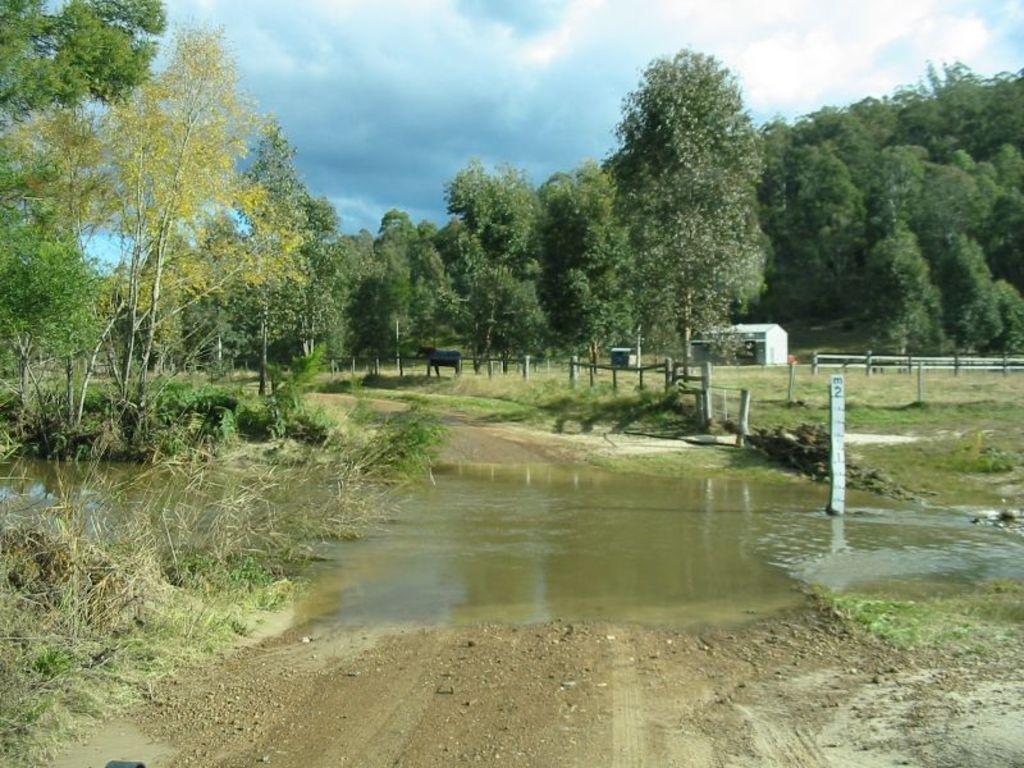Please provide a concise description of this image. At the foreground of the image we can see some water flowing on the road and at the background of the image there are some trees, animal, house and cloudy sky. 